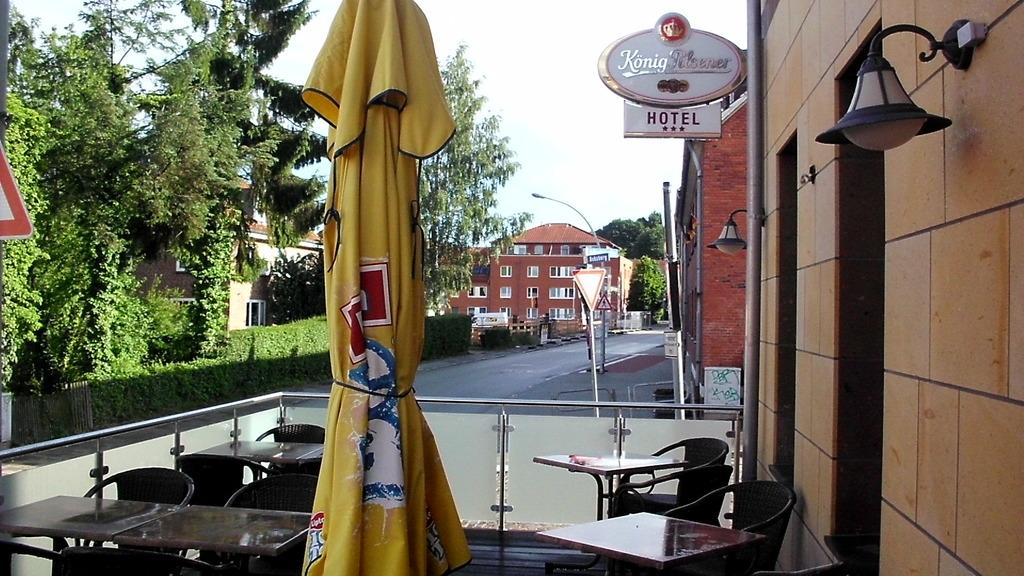What type of furniture is present in the image? There are chairs and tables in the image. What is the color of the cloth visible in the image? The cloth is yellow in color. What can be seen in the background of the image? Buildings, windows, signboards, light-poles, and trees are visible in the background. What is the color of the sky in the image? The sky is white in color. Where is the hook located in the image? There is no hook present in the image. What type of drum can be seen in the image? There is no drum present in the image. 